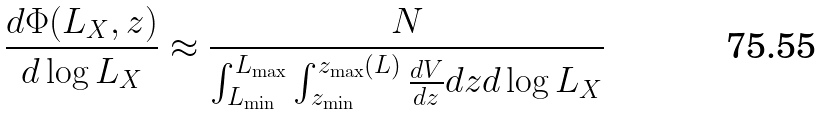Convert formula to latex. <formula><loc_0><loc_0><loc_500><loc_500>\frac { d \Phi ( L _ { X } , z ) } { d \log L _ { X } } \approx \frac { N } { \int _ { L _ { \min } } ^ { L _ { \max } } \int _ { z _ { \min } } ^ { z _ { \max } ( L ) } \frac { d V } { d z } d z d \log L _ { X } }</formula> 